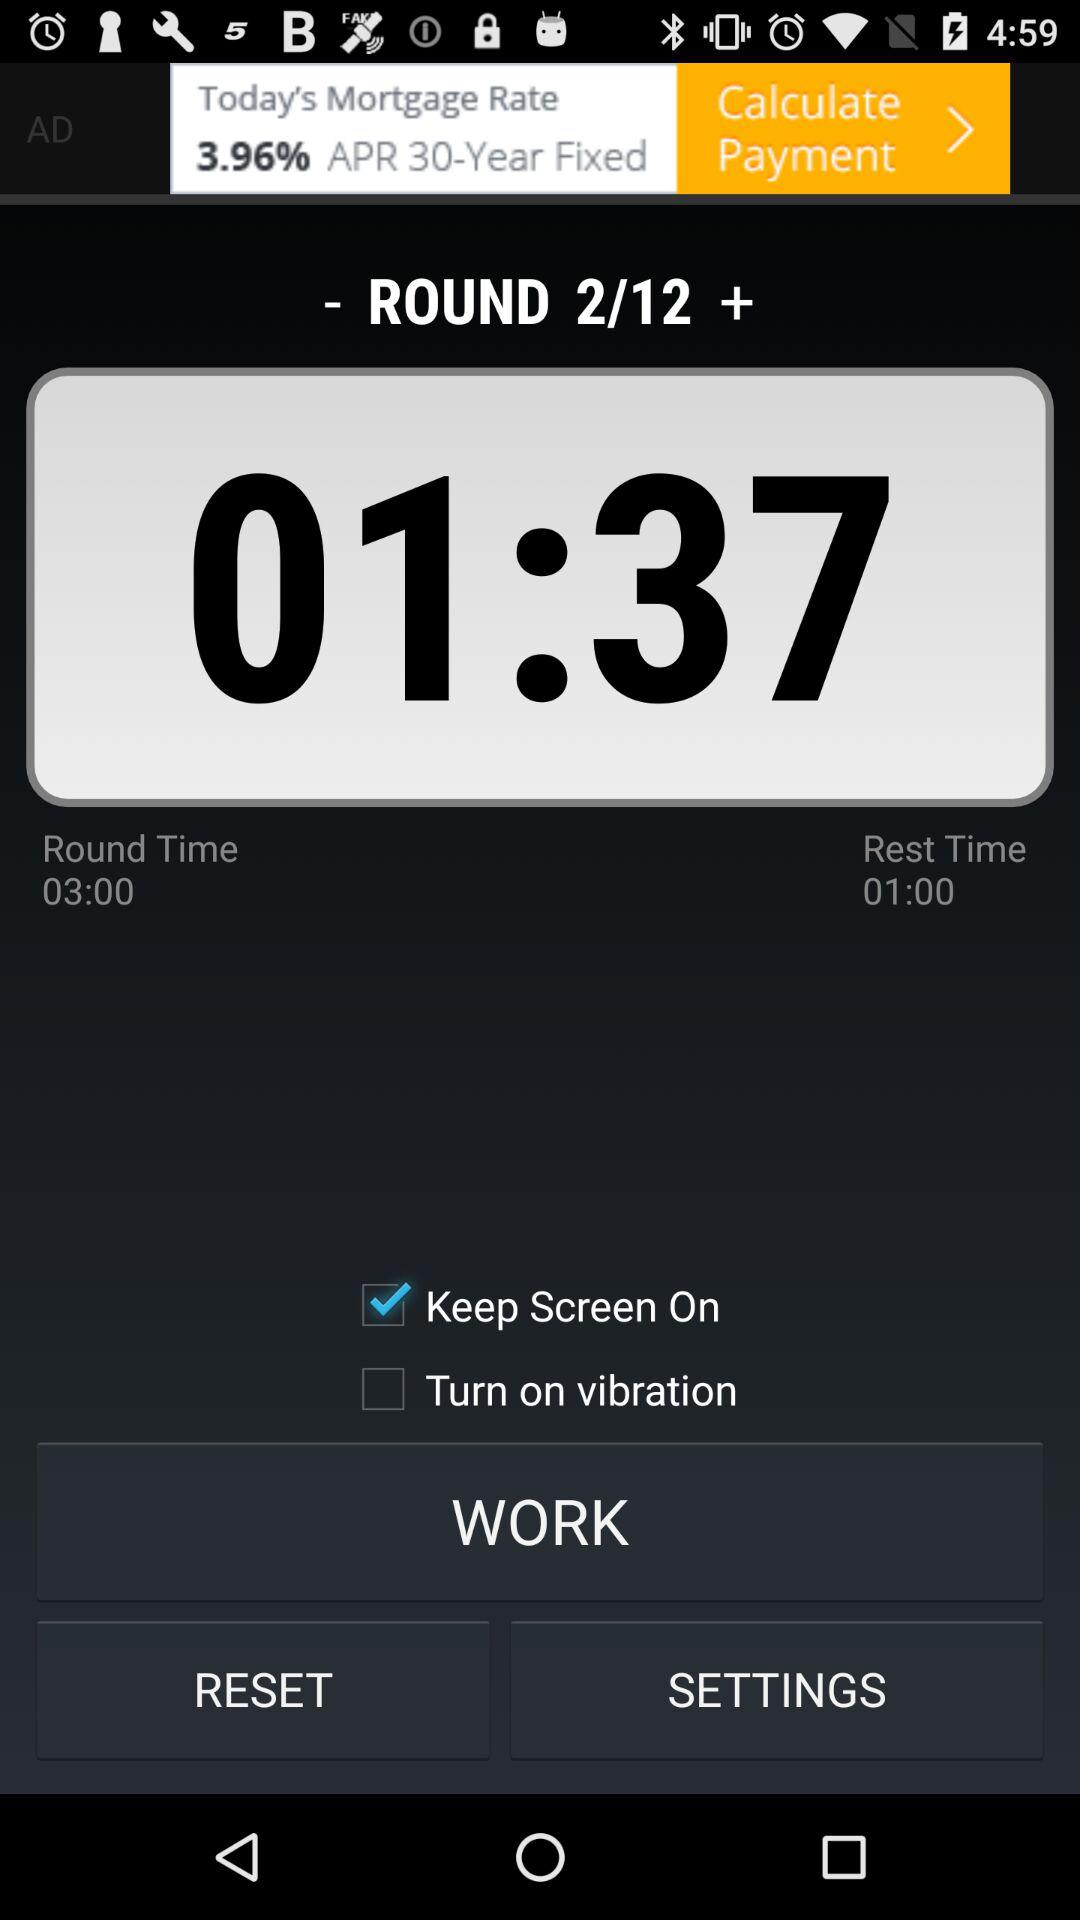What is the second round time? The time is 01:37. 